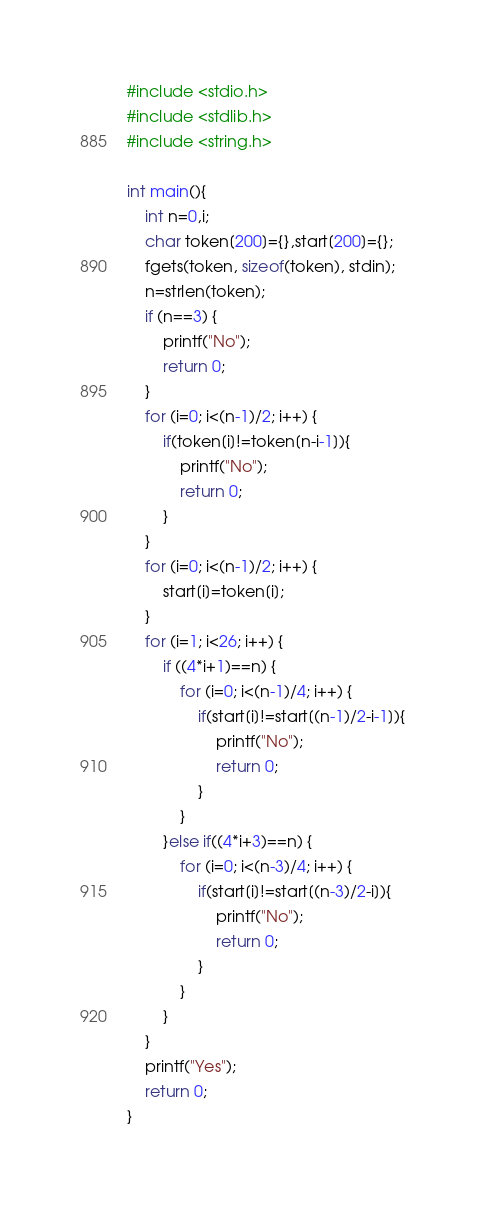<code> <loc_0><loc_0><loc_500><loc_500><_C_>#include <stdio.h>
#include <stdlib.h>
#include <string.h>

int main(){
    int n=0,i;
    char token[200]={},start[200]={};
    fgets(token, sizeof(token), stdin);
    n=strlen(token);
    if (n==3) {
        printf("No");
        return 0;
    }
    for (i=0; i<(n-1)/2; i++) {
        if(token[i]!=token[n-i-1]){
            printf("No");
            return 0;
        }
    }
    for (i=0; i<(n-1)/2; i++) {
        start[i]=token[i];
    }
    for (i=1; i<26; i++) {
        if ((4*i+1)==n) {
            for (i=0; i<(n-1)/4; i++) {
                if(start[i]!=start[(n-1)/2-i-1]){
                    printf("No");
                    return 0;
                }
            }
        }else if((4*i+3)==n) {
            for (i=0; i<(n-3)/4; i++) {
                if(start[i]!=start[(n-3)/2-i]){
                    printf("No");
                    return 0;
                }
            }
        }
    }
    printf("Yes");
    return 0;
}


</code> 